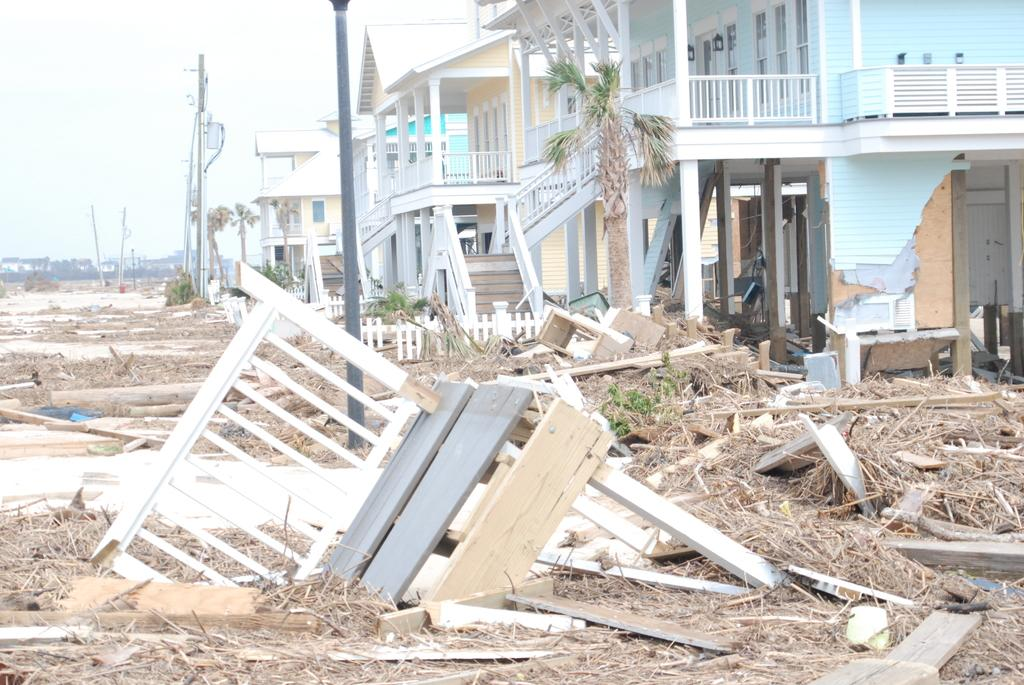What type of objects can be seen on the ground in the image? There are wooden objects and sticks on the ground in the image. What structures are present in the image? There are poles and buildings in the image. What type of natural elements can be seen in the image? There are trees in the image. What else can be seen in the image besides the mentioned objects? There are other objects in the image. What is visible in the background of the image? The sky is visible in the background of the image. How many legs can be seen on the wooden objects in the image? There is no mention of legs on the wooden objects in the image, as they are likely sticks or logs without limbs. What type of liquid is being poured from the poles in the image? There is no liquid present in the image, nor are the poles depicted as having any liquid-related function. 